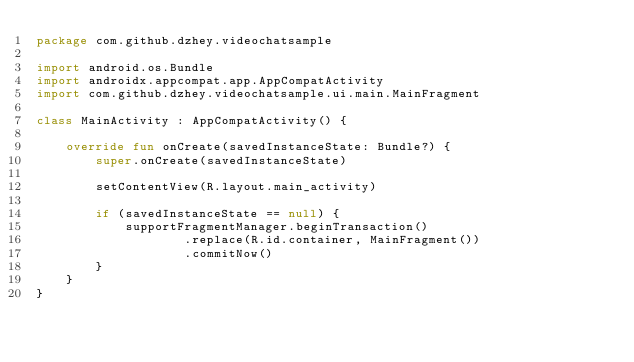<code> <loc_0><loc_0><loc_500><loc_500><_Kotlin_>package com.github.dzhey.videochatsample

import android.os.Bundle
import androidx.appcompat.app.AppCompatActivity
import com.github.dzhey.videochatsample.ui.main.MainFragment

class MainActivity : AppCompatActivity() {

    override fun onCreate(savedInstanceState: Bundle?) {
        super.onCreate(savedInstanceState)

        setContentView(R.layout.main_activity)

        if (savedInstanceState == null) {
            supportFragmentManager.beginTransaction()
                    .replace(R.id.container, MainFragment())
                    .commitNow()
        }
    }
}
</code> 